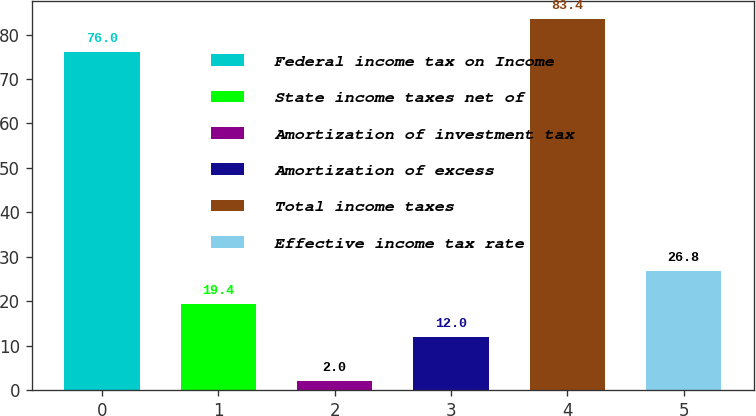Convert chart. <chart><loc_0><loc_0><loc_500><loc_500><bar_chart><fcel>Federal income tax on Income<fcel>State income taxes net of<fcel>Amortization of investment tax<fcel>Amortization of excess<fcel>Total income taxes<fcel>Effective income tax rate<nl><fcel>76<fcel>19.4<fcel>2<fcel>12<fcel>83.4<fcel>26.8<nl></chart> 